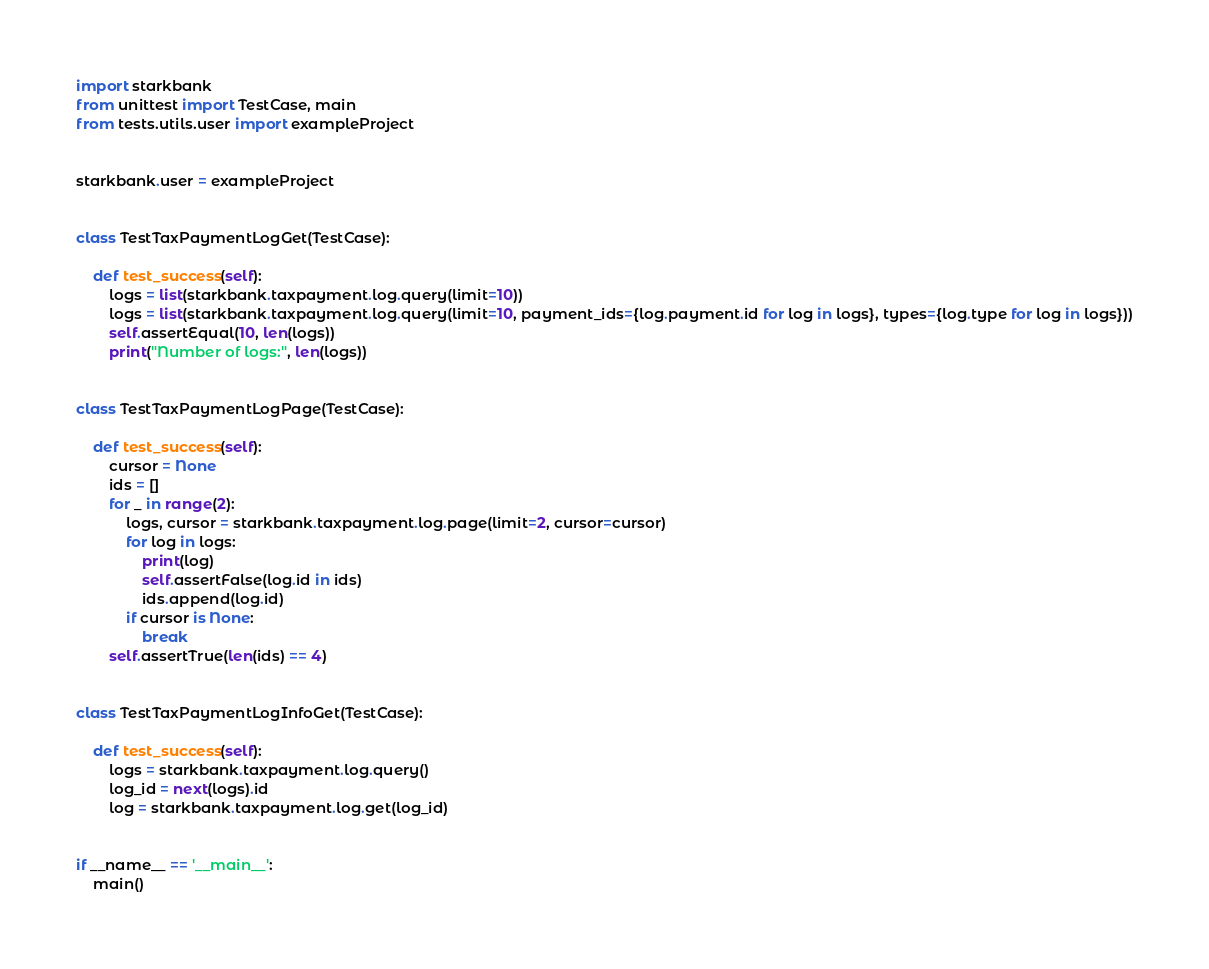<code> <loc_0><loc_0><loc_500><loc_500><_Python_>import starkbank
from unittest import TestCase, main
from tests.utils.user import exampleProject


starkbank.user = exampleProject


class TestTaxPaymentLogGet(TestCase):

    def test_success(self):
        logs = list(starkbank.taxpayment.log.query(limit=10))
        logs = list(starkbank.taxpayment.log.query(limit=10, payment_ids={log.payment.id for log in logs}, types={log.type for log in logs}))
        self.assertEqual(10, len(logs))
        print("Number of logs:", len(logs))


class TestTaxPaymentLogPage(TestCase):

    def test_success(self):
        cursor = None
        ids = []
        for _ in range(2):
            logs, cursor = starkbank.taxpayment.log.page(limit=2, cursor=cursor)
            for log in logs:
                print(log)
                self.assertFalse(log.id in ids)
                ids.append(log.id)
            if cursor is None:
                break
        self.assertTrue(len(ids) == 4)


class TestTaxPaymentLogInfoGet(TestCase):

    def test_success(self):
        logs = starkbank.taxpayment.log.query()
        log_id = next(logs).id
        log = starkbank.taxpayment.log.get(log_id)


if __name__ == '__main__':
    main()
</code> 